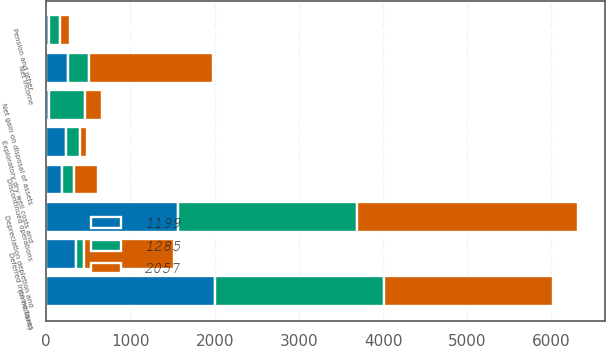Convert chart to OTSL. <chart><loc_0><loc_0><loc_500><loc_500><stacked_bar_chart><ecel><fcel>(In millions)<fcel>Net income<fcel>Discontinued operations<fcel>Deferred income taxes<fcel>Depreciation depletion and<fcel>Pension and other<fcel>Exploratory dry well costs and<fcel>Net gain on disposal of assets<nl><fcel>2057<fcel>2009<fcel>1463<fcel>279<fcel>1072<fcel>2623<fcel>116<fcel>81<fcel>205<nl><fcel>1285<fcel>2008<fcel>256<fcel>144<fcel>94<fcel>2129<fcel>133<fcel>170<fcel>423<nl><fcel>1199<fcel>2007<fcel>256<fcel>190<fcel>352<fcel>1564<fcel>33<fcel>233<fcel>36<nl></chart> 